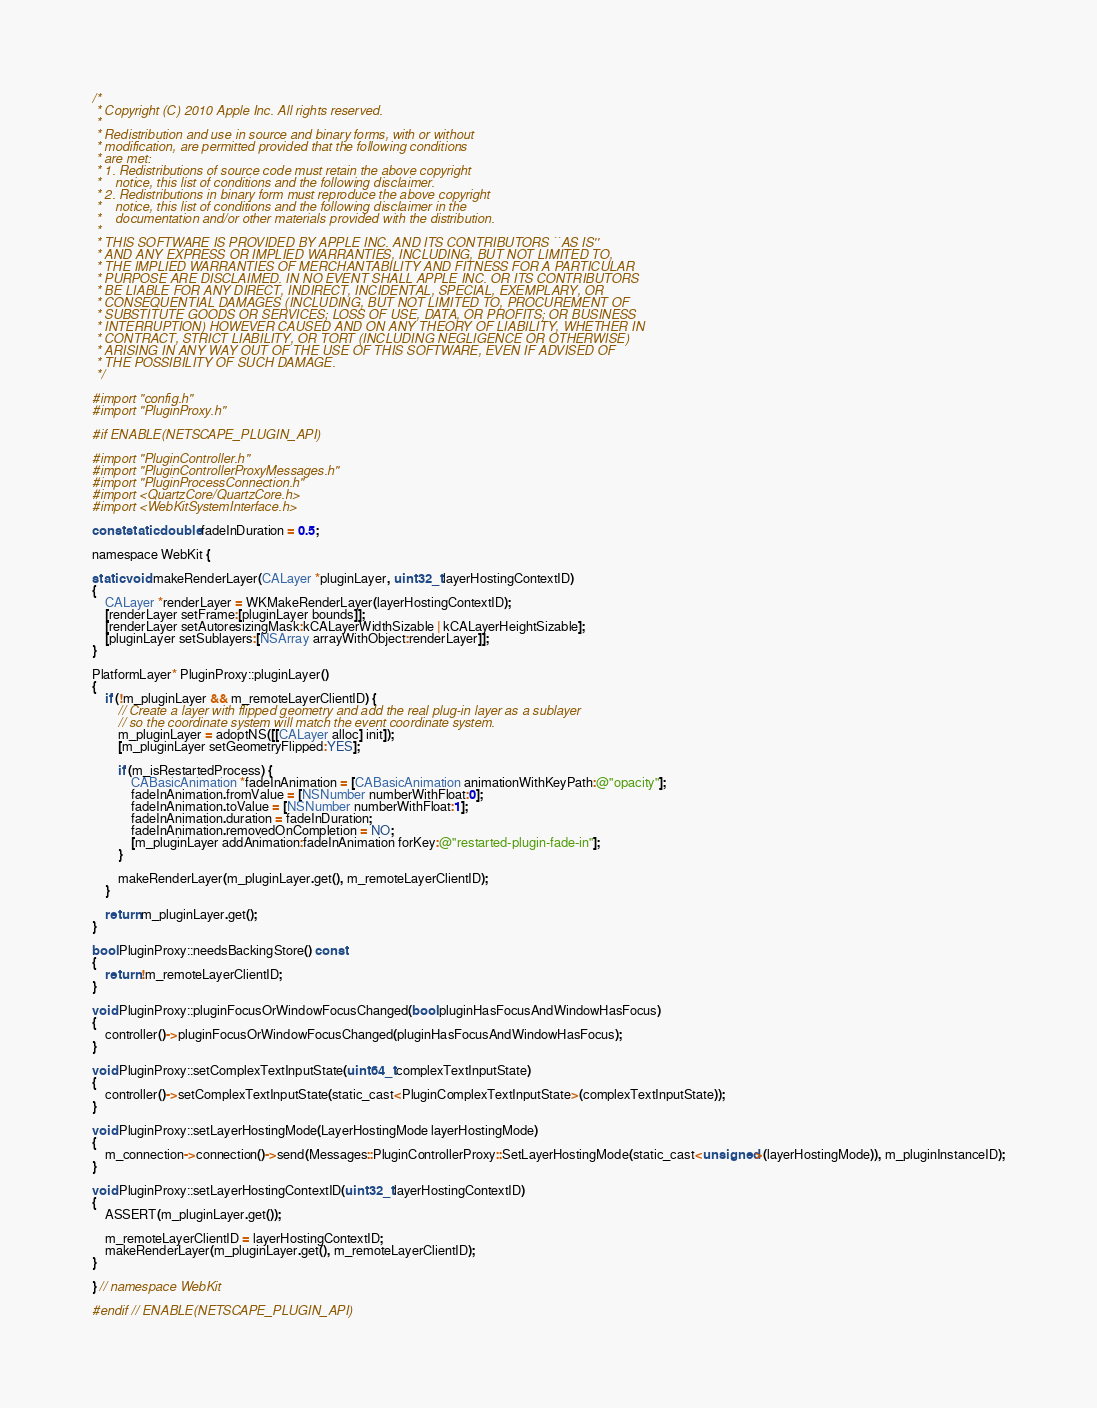Convert code to text. <code><loc_0><loc_0><loc_500><loc_500><_ObjectiveC_>/*
 * Copyright (C) 2010 Apple Inc. All rights reserved.
 *
 * Redistribution and use in source and binary forms, with or without
 * modification, are permitted provided that the following conditions
 * are met:
 * 1. Redistributions of source code must retain the above copyright
 *    notice, this list of conditions and the following disclaimer.
 * 2. Redistributions in binary form must reproduce the above copyright
 *    notice, this list of conditions and the following disclaimer in the
 *    documentation and/or other materials provided with the distribution.
 *
 * THIS SOFTWARE IS PROVIDED BY APPLE INC. AND ITS CONTRIBUTORS ``AS IS''
 * AND ANY EXPRESS OR IMPLIED WARRANTIES, INCLUDING, BUT NOT LIMITED TO,
 * THE IMPLIED WARRANTIES OF MERCHANTABILITY AND FITNESS FOR A PARTICULAR
 * PURPOSE ARE DISCLAIMED. IN NO EVENT SHALL APPLE INC. OR ITS CONTRIBUTORS
 * BE LIABLE FOR ANY DIRECT, INDIRECT, INCIDENTAL, SPECIAL, EXEMPLARY, OR
 * CONSEQUENTIAL DAMAGES (INCLUDING, BUT NOT LIMITED TO, PROCUREMENT OF
 * SUBSTITUTE GOODS OR SERVICES; LOSS OF USE, DATA, OR PROFITS; OR BUSINESS
 * INTERRUPTION) HOWEVER CAUSED AND ON ANY THEORY OF LIABILITY, WHETHER IN
 * CONTRACT, STRICT LIABILITY, OR TORT (INCLUDING NEGLIGENCE OR OTHERWISE)
 * ARISING IN ANY WAY OUT OF THE USE OF THIS SOFTWARE, EVEN IF ADVISED OF
 * THE POSSIBILITY OF SUCH DAMAGE.
 */

#import "config.h"
#import "PluginProxy.h"

#if ENABLE(NETSCAPE_PLUGIN_API)

#import "PluginController.h"
#import "PluginControllerProxyMessages.h"
#import "PluginProcessConnection.h"
#import <QuartzCore/QuartzCore.h>
#import <WebKitSystemInterface.h>

const static double fadeInDuration = 0.5;

namespace WebKit {

static void makeRenderLayer(CALayer *pluginLayer, uint32_t layerHostingContextID)
{
    CALayer *renderLayer = WKMakeRenderLayer(layerHostingContextID);
    [renderLayer setFrame:[pluginLayer bounds]];
    [renderLayer setAutoresizingMask:kCALayerWidthSizable | kCALayerHeightSizable];
    [pluginLayer setSublayers:[NSArray arrayWithObject:renderLayer]];
}

PlatformLayer* PluginProxy::pluginLayer()
{
    if (!m_pluginLayer && m_remoteLayerClientID) {
        // Create a layer with flipped geometry and add the real plug-in layer as a sublayer
        // so the coordinate system will match the event coordinate system.
        m_pluginLayer = adoptNS([[CALayer alloc] init]);
        [m_pluginLayer setGeometryFlipped:YES];

        if (m_isRestartedProcess) {
            CABasicAnimation *fadeInAnimation = [CABasicAnimation animationWithKeyPath:@"opacity"];
            fadeInAnimation.fromValue = [NSNumber numberWithFloat:0];
            fadeInAnimation.toValue = [NSNumber numberWithFloat:1];
            fadeInAnimation.duration = fadeInDuration;
            fadeInAnimation.removedOnCompletion = NO;
            [m_pluginLayer addAnimation:fadeInAnimation forKey:@"restarted-plugin-fade-in"];
        }

        makeRenderLayer(m_pluginLayer.get(), m_remoteLayerClientID);
    }

    return m_pluginLayer.get();
}

bool PluginProxy::needsBackingStore() const
{
    return !m_remoteLayerClientID;
}

void PluginProxy::pluginFocusOrWindowFocusChanged(bool pluginHasFocusAndWindowHasFocus)
{
    controller()->pluginFocusOrWindowFocusChanged(pluginHasFocusAndWindowHasFocus);
}

void PluginProxy::setComplexTextInputState(uint64_t complexTextInputState)
{
    controller()->setComplexTextInputState(static_cast<PluginComplexTextInputState>(complexTextInputState));
}

void PluginProxy::setLayerHostingMode(LayerHostingMode layerHostingMode)
{
    m_connection->connection()->send(Messages::PluginControllerProxy::SetLayerHostingMode(static_cast<unsigned>(layerHostingMode)), m_pluginInstanceID);
}

void PluginProxy::setLayerHostingContextID(uint32_t layerHostingContextID)
{
    ASSERT(m_pluginLayer.get());

    m_remoteLayerClientID = layerHostingContextID;
    makeRenderLayer(m_pluginLayer.get(), m_remoteLayerClientID);
}

} // namespace WebKit

#endif // ENABLE(NETSCAPE_PLUGIN_API)
</code> 